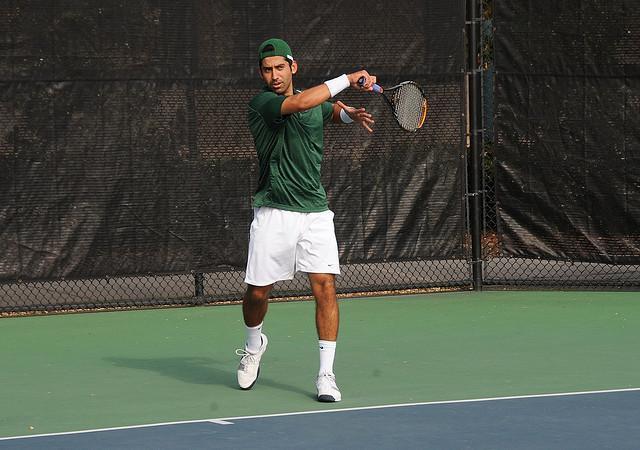How many chairs are behind the pole?
Give a very brief answer. 0. 